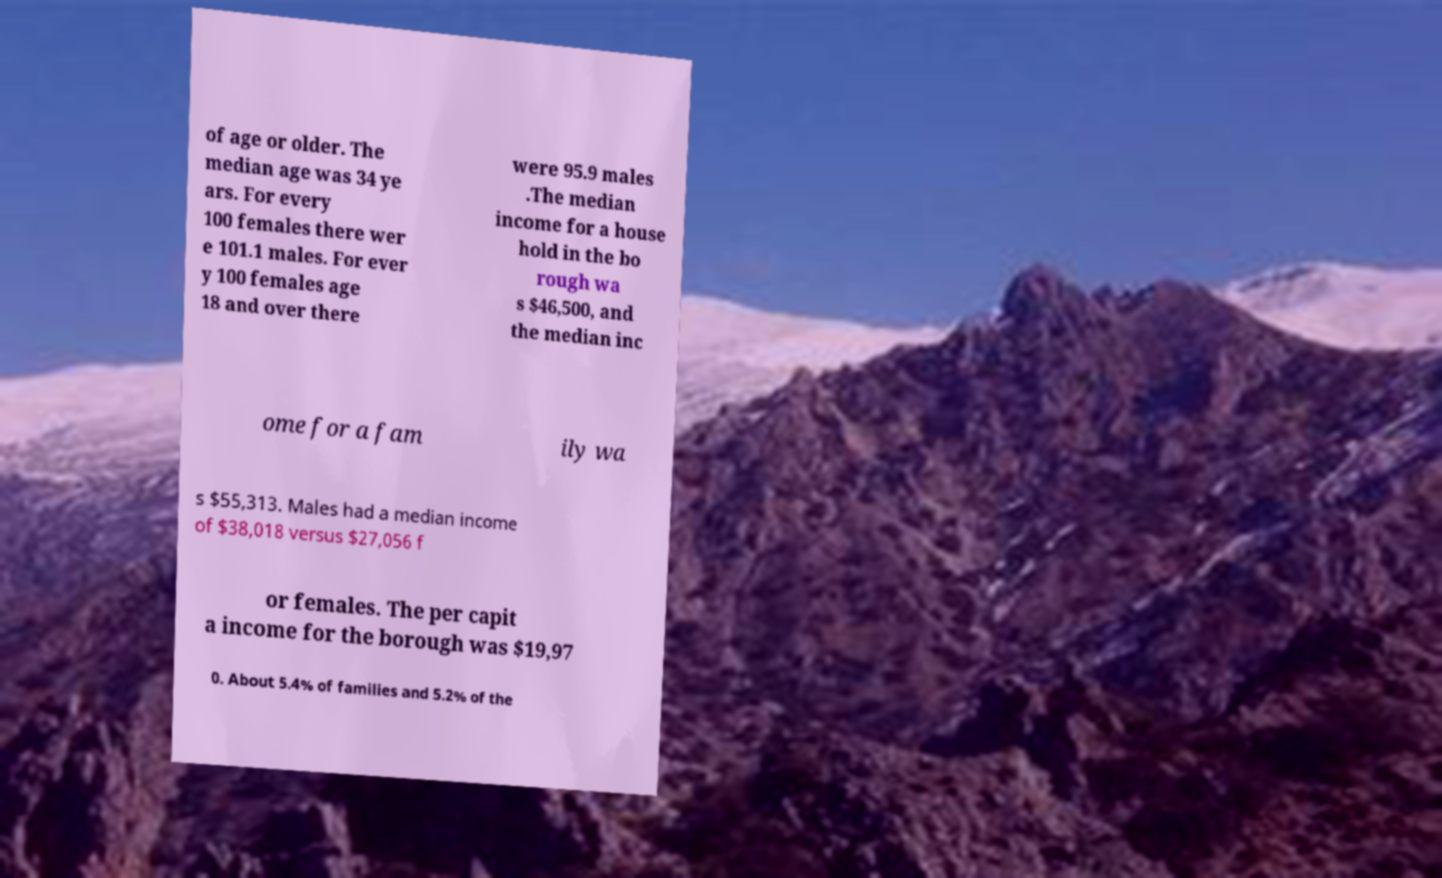Can you read and provide the text displayed in the image?This photo seems to have some interesting text. Can you extract and type it out for me? of age or older. The median age was 34 ye ars. For every 100 females there wer e 101.1 males. For ever y 100 females age 18 and over there were 95.9 males .The median income for a house hold in the bo rough wa s $46,500, and the median inc ome for a fam ily wa s $55,313. Males had a median income of $38,018 versus $27,056 f or females. The per capit a income for the borough was $19,97 0. About 5.4% of families and 5.2% of the 